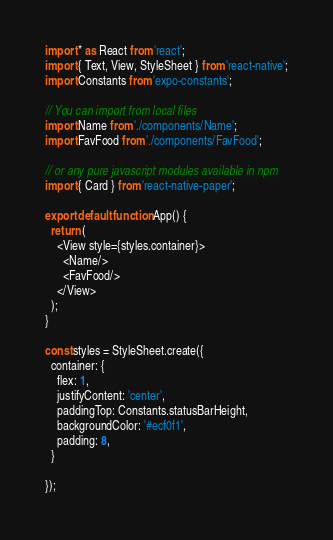<code> <loc_0><loc_0><loc_500><loc_500><_JavaScript_>import * as React from 'react';
import { Text, View, StyleSheet } from 'react-native';
import Constants from 'expo-constants';

// You can import from local files
import Name from './components/Name';
import FavFood from './components/FavFood';

// or any pure javascript modules available in npm
import { Card } from 'react-native-paper';

export default function App() {
  return (
    <View style={styles.container}>
      <Name/>
      <FavFood/>
    </View>
  );
}

const styles = StyleSheet.create({
  container: {
    flex: 1,
    justifyContent: 'center',
    paddingTop: Constants.statusBarHeight,
    backgroundColor: '#ecf0f1',
    padding: 8,
  }
  
});
</code> 